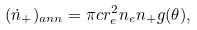Convert formula to latex. <formula><loc_0><loc_0><loc_500><loc_500>( \dot { n } _ { + } ) _ { a n n } = \pi c r _ { e } ^ { 2 } n _ { e } n _ { + } g ( \theta ) ,</formula> 